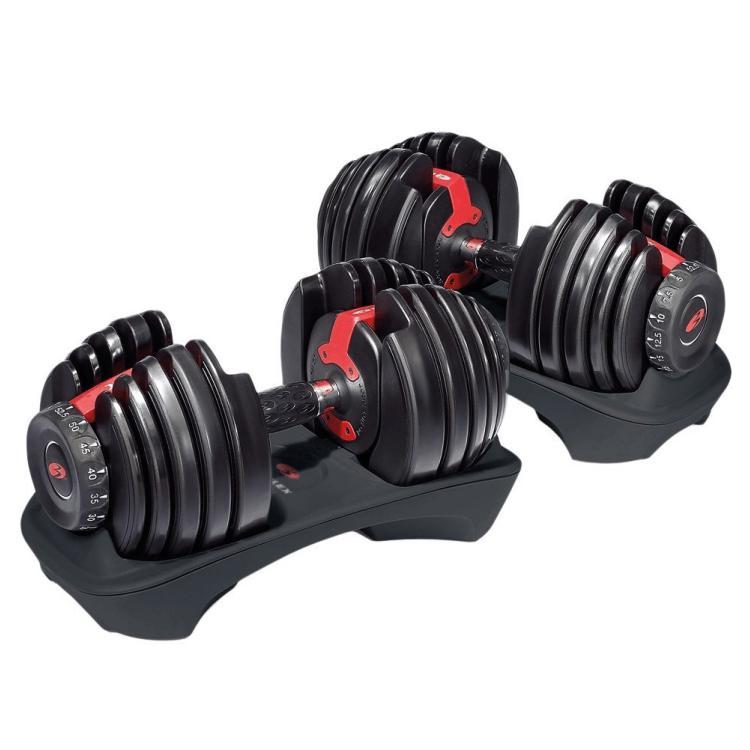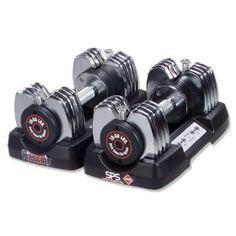The first image is the image on the left, the second image is the image on the right. Examine the images to the left and right. Is the description "The left and right image contains a total of four dumbbells and four racks." accurate? Answer yes or no. Yes. The first image is the image on the left, the second image is the image on the right. Examine the images to the left and right. Is the description "There are four barbell stands." accurate? Answer yes or no. Yes. 